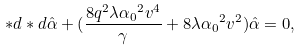Convert formula to latex. <formula><loc_0><loc_0><loc_500><loc_500>* d * d \hat { \alpha } + ( \frac { 8 q ^ { 2 } \lambda { \alpha _ { 0 } } ^ { 2 } v ^ { 4 } } { \gamma } + 8 \lambda { \alpha _ { 0 } } ^ { 2 } v ^ { 2 } ) \hat { \alpha } = 0 ,</formula> 